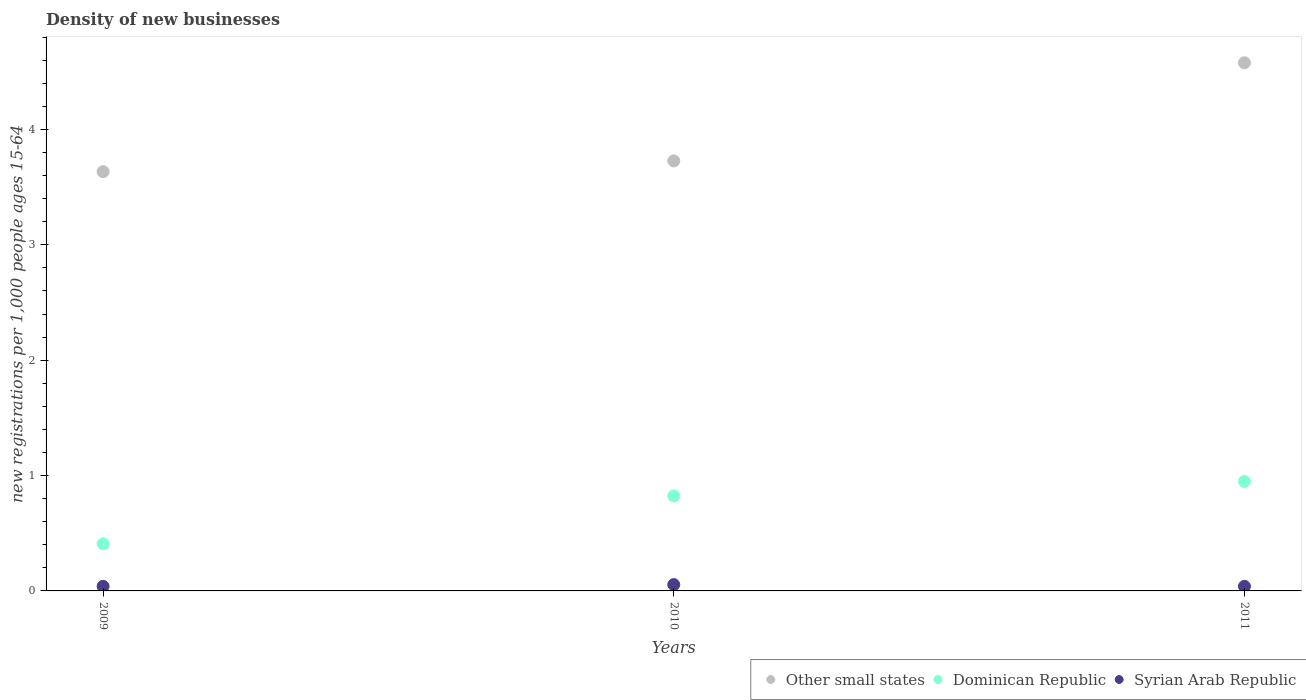What is the number of new registrations in Other small states in 2009?
Make the answer very short. 3.63. Across all years, what is the maximum number of new registrations in Dominican Republic?
Ensure brevity in your answer.  0.95. Across all years, what is the minimum number of new registrations in Other small states?
Your response must be concise. 3.63. In which year was the number of new registrations in Syrian Arab Republic minimum?
Provide a succinct answer. 2009. What is the total number of new registrations in Other small states in the graph?
Your answer should be very brief. 11.94. What is the difference between the number of new registrations in Dominican Republic in 2010 and that in 2011?
Offer a terse response. -0.13. What is the difference between the number of new registrations in Syrian Arab Republic in 2011 and the number of new registrations in Dominican Republic in 2010?
Offer a very short reply. -0.78. What is the average number of new registrations in Other small states per year?
Provide a succinct answer. 3.98. In the year 2010, what is the difference between the number of new registrations in Syrian Arab Republic and number of new registrations in Other small states?
Your answer should be compact. -3.67. What is the ratio of the number of new registrations in Dominican Republic in 2009 to that in 2011?
Your answer should be very brief. 0.43. Is the number of new registrations in Dominican Republic in 2010 less than that in 2011?
Provide a short and direct response. Yes. Is the difference between the number of new registrations in Syrian Arab Republic in 2010 and 2011 greater than the difference between the number of new registrations in Other small states in 2010 and 2011?
Your answer should be compact. Yes. What is the difference between the highest and the second highest number of new registrations in Other small states?
Keep it short and to the point. 0.85. What is the difference between the highest and the lowest number of new registrations in Syrian Arab Republic?
Make the answer very short. 0.02. Is the sum of the number of new registrations in Other small states in 2009 and 2011 greater than the maximum number of new registrations in Dominican Republic across all years?
Ensure brevity in your answer.  Yes. Is it the case that in every year, the sum of the number of new registrations in Other small states and number of new registrations in Syrian Arab Republic  is greater than the number of new registrations in Dominican Republic?
Keep it short and to the point. Yes. Does the number of new registrations in Dominican Republic monotonically increase over the years?
Provide a short and direct response. Yes. Is the number of new registrations in Other small states strictly greater than the number of new registrations in Dominican Republic over the years?
Your answer should be very brief. Yes. Is the number of new registrations in Syrian Arab Republic strictly less than the number of new registrations in Dominican Republic over the years?
Offer a very short reply. Yes. What is the difference between two consecutive major ticks on the Y-axis?
Keep it short and to the point. 1. Does the graph contain grids?
Make the answer very short. No. How many legend labels are there?
Ensure brevity in your answer.  3. What is the title of the graph?
Provide a short and direct response. Density of new businesses. Does "Serbia" appear as one of the legend labels in the graph?
Ensure brevity in your answer.  No. What is the label or title of the Y-axis?
Make the answer very short. New registrations per 1,0 people ages 15-64. What is the new registrations per 1,000 people ages 15-64 of Other small states in 2009?
Give a very brief answer. 3.63. What is the new registrations per 1,000 people ages 15-64 in Dominican Republic in 2009?
Provide a short and direct response. 0.41. What is the new registrations per 1,000 people ages 15-64 in Syrian Arab Republic in 2009?
Make the answer very short. 0.04. What is the new registrations per 1,000 people ages 15-64 in Other small states in 2010?
Your answer should be compact. 3.73. What is the new registrations per 1,000 people ages 15-64 in Dominican Republic in 2010?
Keep it short and to the point. 0.82. What is the new registrations per 1,000 people ages 15-64 of Syrian Arab Republic in 2010?
Your answer should be compact. 0.05. What is the new registrations per 1,000 people ages 15-64 of Other small states in 2011?
Your response must be concise. 4.58. What is the new registrations per 1,000 people ages 15-64 of Dominican Republic in 2011?
Make the answer very short. 0.95. What is the new registrations per 1,000 people ages 15-64 in Syrian Arab Republic in 2011?
Give a very brief answer. 0.04. Across all years, what is the maximum new registrations per 1,000 people ages 15-64 in Other small states?
Provide a succinct answer. 4.58. Across all years, what is the maximum new registrations per 1,000 people ages 15-64 in Dominican Republic?
Keep it short and to the point. 0.95. Across all years, what is the maximum new registrations per 1,000 people ages 15-64 in Syrian Arab Republic?
Keep it short and to the point. 0.05. Across all years, what is the minimum new registrations per 1,000 people ages 15-64 of Other small states?
Offer a very short reply. 3.63. Across all years, what is the minimum new registrations per 1,000 people ages 15-64 of Dominican Republic?
Offer a very short reply. 0.41. Across all years, what is the minimum new registrations per 1,000 people ages 15-64 in Syrian Arab Republic?
Your answer should be very brief. 0.04. What is the total new registrations per 1,000 people ages 15-64 in Other small states in the graph?
Give a very brief answer. 11.94. What is the total new registrations per 1,000 people ages 15-64 of Dominican Republic in the graph?
Give a very brief answer. 2.18. What is the total new registrations per 1,000 people ages 15-64 in Syrian Arab Republic in the graph?
Offer a very short reply. 0.13. What is the difference between the new registrations per 1,000 people ages 15-64 in Other small states in 2009 and that in 2010?
Ensure brevity in your answer.  -0.09. What is the difference between the new registrations per 1,000 people ages 15-64 of Dominican Republic in 2009 and that in 2010?
Your answer should be very brief. -0.41. What is the difference between the new registrations per 1,000 people ages 15-64 in Syrian Arab Republic in 2009 and that in 2010?
Provide a short and direct response. -0.02. What is the difference between the new registrations per 1,000 people ages 15-64 in Other small states in 2009 and that in 2011?
Your response must be concise. -0.94. What is the difference between the new registrations per 1,000 people ages 15-64 of Dominican Republic in 2009 and that in 2011?
Provide a succinct answer. -0.54. What is the difference between the new registrations per 1,000 people ages 15-64 of Syrian Arab Republic in 2009 and that in 2011?
Your response must be concise. -0. What is the difference between the new registrations per 1,000 people ages 15-64 in Other small states in 2010 and that in 2011?
Give a very brief answer. -0.85. What is the difference between the new registrations per 1,000 people ages 15-64 in Dominican Republic in 2010 and that in 2011?
Ensure brevity in your answer.  -0.13. What is the difference between the new registrations per 1,000 people ages 15-64 of Syrian Arab Republic in 2010 and that in 2011?
Provide a short and direct response. 0.01. What is the difference between the new registrations per 1,000 people ages 15-64 in Other small states in 2009 and the new registrations per 1,000 people ages 15-64 in Dominican Republic in 2010?
Provide a short and direct response. 2.81. What is the difference between the new registrations per 1,000 people ages 15-64 of Other small states in 2009 and the new registrations per 1,000 people ages 15-64 of Syrian Arab Republic in 2010?
Keep it short and to the point. 3.58. What is the difference between the new registrations per 1,000 people ages 15-64 in Dominican Republic in 2009 and the new registrations per 1,000 people ages 15-64 in Syrian Arab Republic in 2010?
Offer a very short reply. 0.35. What is the difference between the new registrations per 1,000 people ages 15-64 in Other small states in 2009 and the new registrations per 1,000 people ages 15-64 in Dominican Republic in 2011?
Keep it short and to the point. 2.69. What is the difference between the new registrations per 1,000 people ages 15-64 in Other small states in 2009 and the new registrations per 1,000 people ages 15-64 in Syrian Arab Republic in 2011?
Provide a short and direct response. 3.59. What is the difference between the new registrations per 1,000 people ages 15-64 of Dominican Republic in 2009 and the new registrations per 1,000 people ages 15-64 of Syrian Arab Republic in 2011?
Your answer should be compact. 0.37. What is the difference between the new registrations per 1,000 people ages 15-64 in Other small states in 2010 and the new registrations per 1,000 people ages 15-64 in Dominican Republic in 2011?
Ensure brevity in your answer.  2.78. What is the difference between the new registrations per 1,000 people ages 15-64 in Other small states in 2010 and the new registrations per 1,000 people ages 15-64 in Syrian Arab Republic in 2011?
Your response must be concise. 3.69. What is the difference between the new registrations per 1,000 people ages 15-64 of Dominican Republic in 2010 and the new registrations per 1,000 people ages 15-64 of Syrian Arab Republic in 2011?
Provide a succinct answer. 0.78. What is the average new registrations per 1,000 people ages 15-64 in Other small states per year?
Your response must be concise. 3.98. What is the average new registrations per 1,000 people ages 15-64 of Dominican Republic per year?
Provide a succinct answer. 0.73. What is the average new registrations per 1,000 people ages 15-64 of Syrian Arab Republic per year?
Your answer should be very brief. 0.04. In the year 2009, what is the difference between the new registrations per 1,000 people ages 15-64 of Other small states and new registrations per 1,000 people ages 15-64 of Dominican Republic?
Provide a succinct answer. 3.23. In the year 2009, what is the difference between the new registrations per 1,000 people ages 15-64 in Other small states and new registrations per 1,000 people ages 15-64 in Syrian Arab Republic?
Provide a short and direct response. 3.59. In the year 2009, what is the difference between the new registrations per 1,000 people ages 15-64 in Dominican Republic and new registrations per 1,000 people ages 15-64 in Syrian Arab Republic?
Your answer should be very brief. 0.37. In the year 2010, what is the difference between the new registrations per 1,000 people ages 15-64 in Other small states and new registrations per 1,000 people ages 15-64 in Dominican Republic?
Offer a terse response. 2.9. In the year 2010, what is the difference between the new registrations per 1,000 people ages 15-64 in Other small states and new registrations per 1,000 people ages 15-64 in Syrian Arab Republic?
Offer a terse response. 3.67. In the year 2010, what is the difference between the new registrations per 1,000 people ages 15-64 of Dominican Republic and new registrations per 1,000 people ages 15-64 of Syrian Arab Republic?
Your answer should be very brief. 0.77. In the year 2011, what is the difference between the new registrations per 1,000 people ages 15-64 of Other small states and new registrations per 1,000 people ages 15-64 of Dominican Republic?
Your answer should be very brief. 3.63. In the year 2011, what is the difference between the new registrations per 1,000 people ages 15-64 of Other small states and new registrations per 1,000 people ages 15-64 of Syrian Arab Republic?
Make the answer very short. 4.54. In the year 2011, what is the difference between the new registrations per 1,000 people ages 15-64 in Dominican Republic and new registrations per 1,000 people ages 15-64 in Syrian Arab Republic?
Offer a terse response. 0.91. What is the ratio of the new registrations per 1,000 people ages 15-64 in Other small states in 2009 to that in 2010?
Offer a terse response. 0.98. What is the ratio of the new registrations per 1,000 people ages 15-64 of Dominican Republic in 2009 to that in 2010?
Your answer should be compact. 0.5. What is the ratio of the new registrations per 1,000 people ages 15-64 in Syrian Arab Republic in 2009 to that in 2010?
Make the answer very short. 0.72. What is the ratio of the new registrations per 1,000 people ages 15-64 in Other small states in 2009 to that in 2011?
Provide a short and direct response. 0.79. What is the ratio of the new registrations per 1,000 people ages 15-64 of Dominican Republic in 2009 to that in 2011?
Make the answer very short. 0.43. What is the ratio of the new registrations per 1,000 people ages 15-64 in Syrian Arab Republic in 2009 to that in 2011?
Make the answer very short. 0.99. What is the ratio of the new registrations per 1,000 people ages 15-64 in Other small states in 2010 to that in 2011?
Your response must be concise. 0.81. What is the ratio of the new registrations per 1,000 people ages 15-64 of Dominican Republic in 2010 to that in 2011?
Make the answer very short. 0.87. What is the ratio of the new registrations per 1,000 people ages 15-64 of Syrian Arab Republic in 2010 to that in 2011?
Your response must be concise. 1.37. What is the difference between the highest and the second highest new registrations per 1,000 people ages 15-64 of Other small states?
Your answer should be compact. 0.85. What is the difference between the highest and the second highest new registrations per 1,000 people ages 15-64 in Dominican Republic?
Keep it short and to the point. 0.13. What is the difference between the highest and the second highest new registrations per 1,000 people ages 15-64 of Syrian Arab Republic?
Provide a short and direct response. 0.01. What is the difference between the highest and the lowest new registrations per 1,000 people ages 15-64 in Other small states?
Provide a succinct answer. 0.94. What is the difference between the highest and the lowest new registrations per 1,000 people ages 15-64 of Dominican Republic?
Your answer should be very brief. 0.54. What is the difference between the highest and the lowest new registrations per 1,000 people ages 15-64 in Syrian Arab Republic?
Keep it short and to the point. 0.02. 